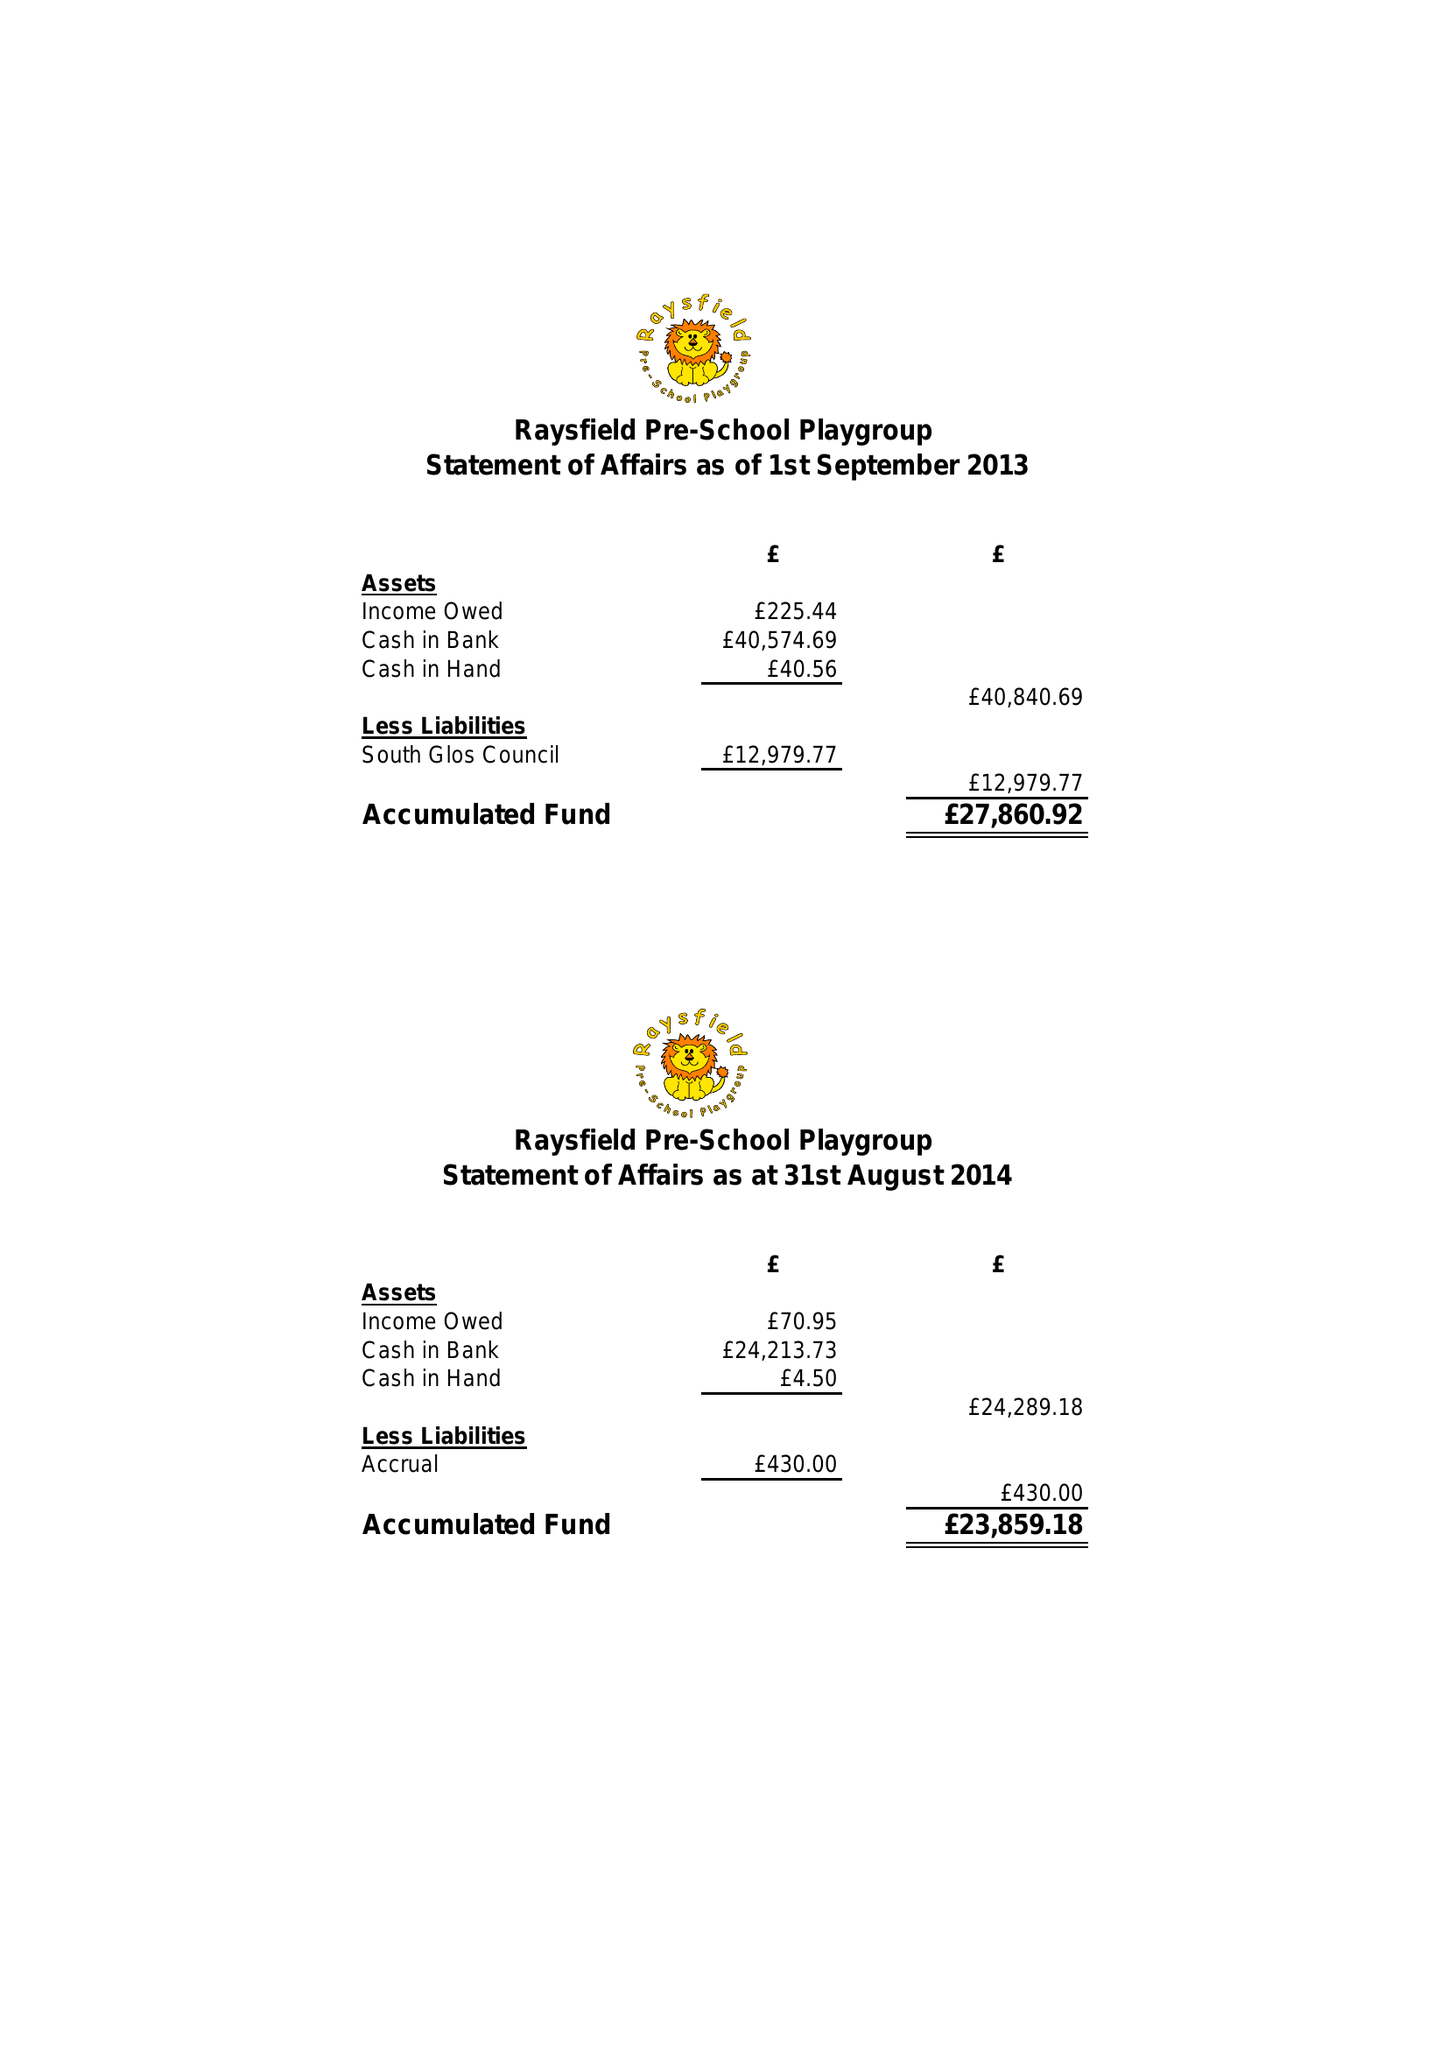What is the value for the report_date?
Answer the question using a single word or phrase. 2014-08-31 